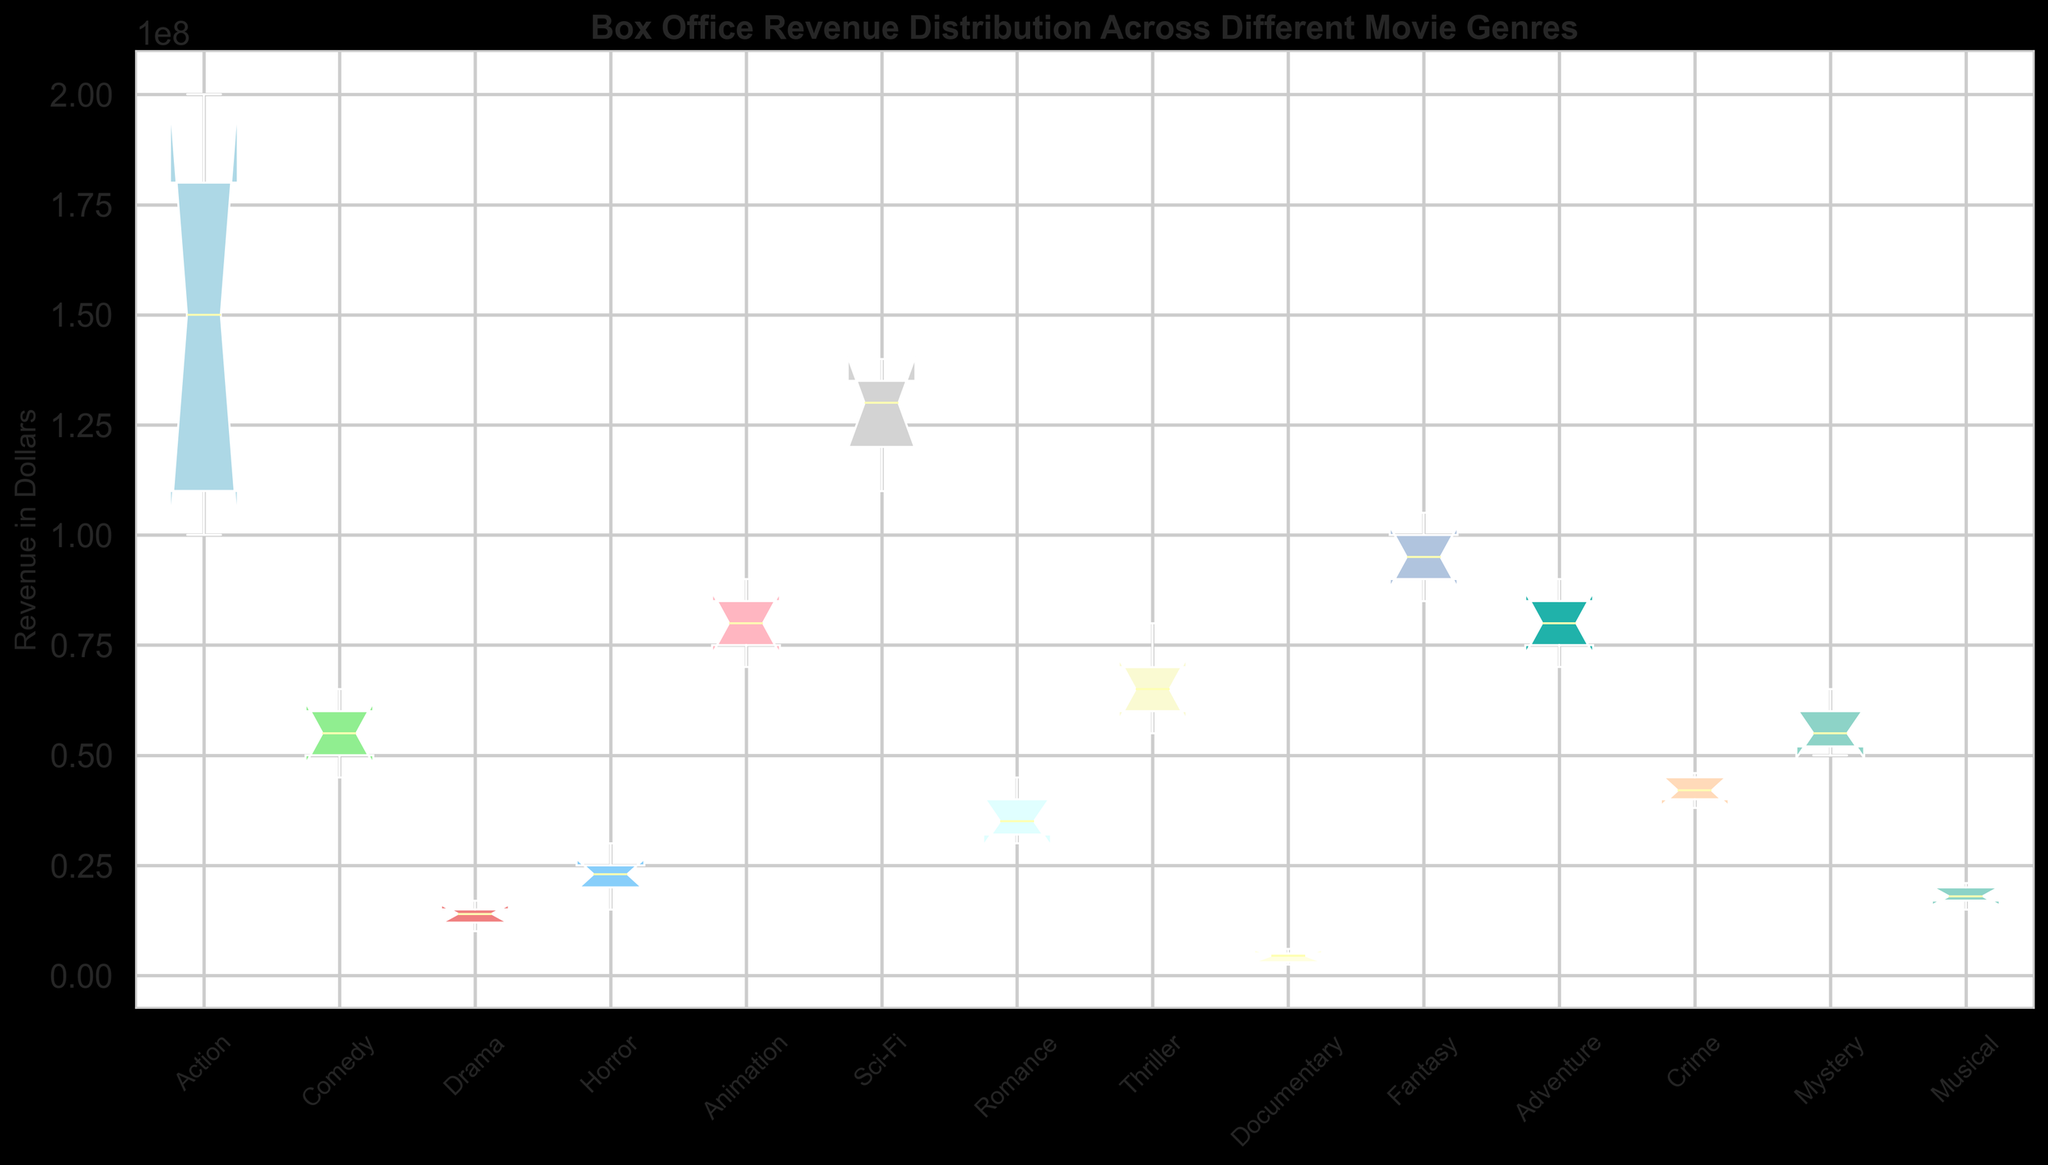Which genre has the highest median revenue? The median is the middle value when the revenues of each genre are listed in order. According to the box plot, Sci-Fi has the highest median, as the line inside the Sci-Fi box is higher than those in the other boxes.
Answer: Sci-Fi Which genre shows the greatest variation in revenue? The variation can be seen by comparing the length of the boxes and their whiskers. The Action genre has the longest whiskers and the widest spread between the quartiles, indicating the greatest variation.
Answer: Action Which genre has the smallest interquartile range for its revenue? The interquartile range (IQR) is the range of the middle 50% of the data, shown by the length of the box. The Documentary genre has the smallest box, indicating the smallest IQR.
Answer: Documentary What is the approximate range of revenues for the Comedy genre? The range is the difference between the maximum and minimum values. In the Comedy box plot, the whiskers extend from about $45,000,000 to $65,000,000.
Answer: $20,000,000 How do the median revenues of Animation and Fantasy compare? The median for Animation is around $80,000,000 and for Fantasy, it is around $95,000,000. By comparing the height of the boxes' midlines, we see that Fantasy has a higher median than Animation.
Answer: Fantasy has a higher median than Animation Which genre has the lowest maximum revenue? The maximum revenue is indicated by the top whisker. The Documentary genre has the shortest top whisker, showing the lowest maximum revenue.
Answer: Documentary What is the approximate median revenue of the Horror genre? By locating the middle line in the Horror box, we see that it is around $23,000,000.
Answer: $23,000,000 Compare the revenue distribution between Drama and Romance genres. Which one has more consistent earnings? Consistent earnings are indicated by a smaller IQR. The Romance genre has a smaller box compared to Drama, indicating more consistent earnings.
Answer: Romance By comparing the highest extreme points, which genre stands out the most? The highest extreme point is indicated by the top whisker. Sci-Fi stands out with the highest top whisker, indicating the highest extreme revenue.
Answer: Sci-Fi Which genre appears to have outliers, if any? Outliers can be represented by points outside the whiskers' range. The box plot does not show any specific outliers for any genre.
Answer: None 